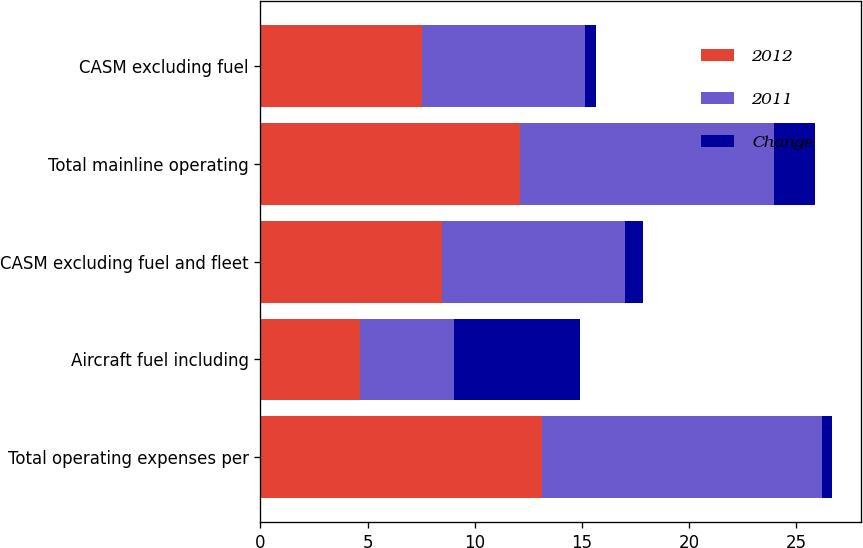Convert chart. <chart><loc_0><loc_0><loc_500><loc_500><stacked_bar_chart><ecel><fcel>Total operating expenses per<fcel>Aircraft fuel including<fcel>CASM excluding fuel and fleet<fcel>Total mainline operating<fcel>CASM excluding fuel<nl><fcel>2012<fcel>13.12<fcel>4.64<fcel>8.48<fcel>12.09<fcel>7.56<nl><fcel>2011<fcel>13.06<fcel>4.38<fcel>8.55<fcel>11.87<fcel>7.6<nl><fcel>Change<fcel>0.5<fcel>5.9<fcel>0.8<fcel>1.9<fcel>0.5<nl></chart> 